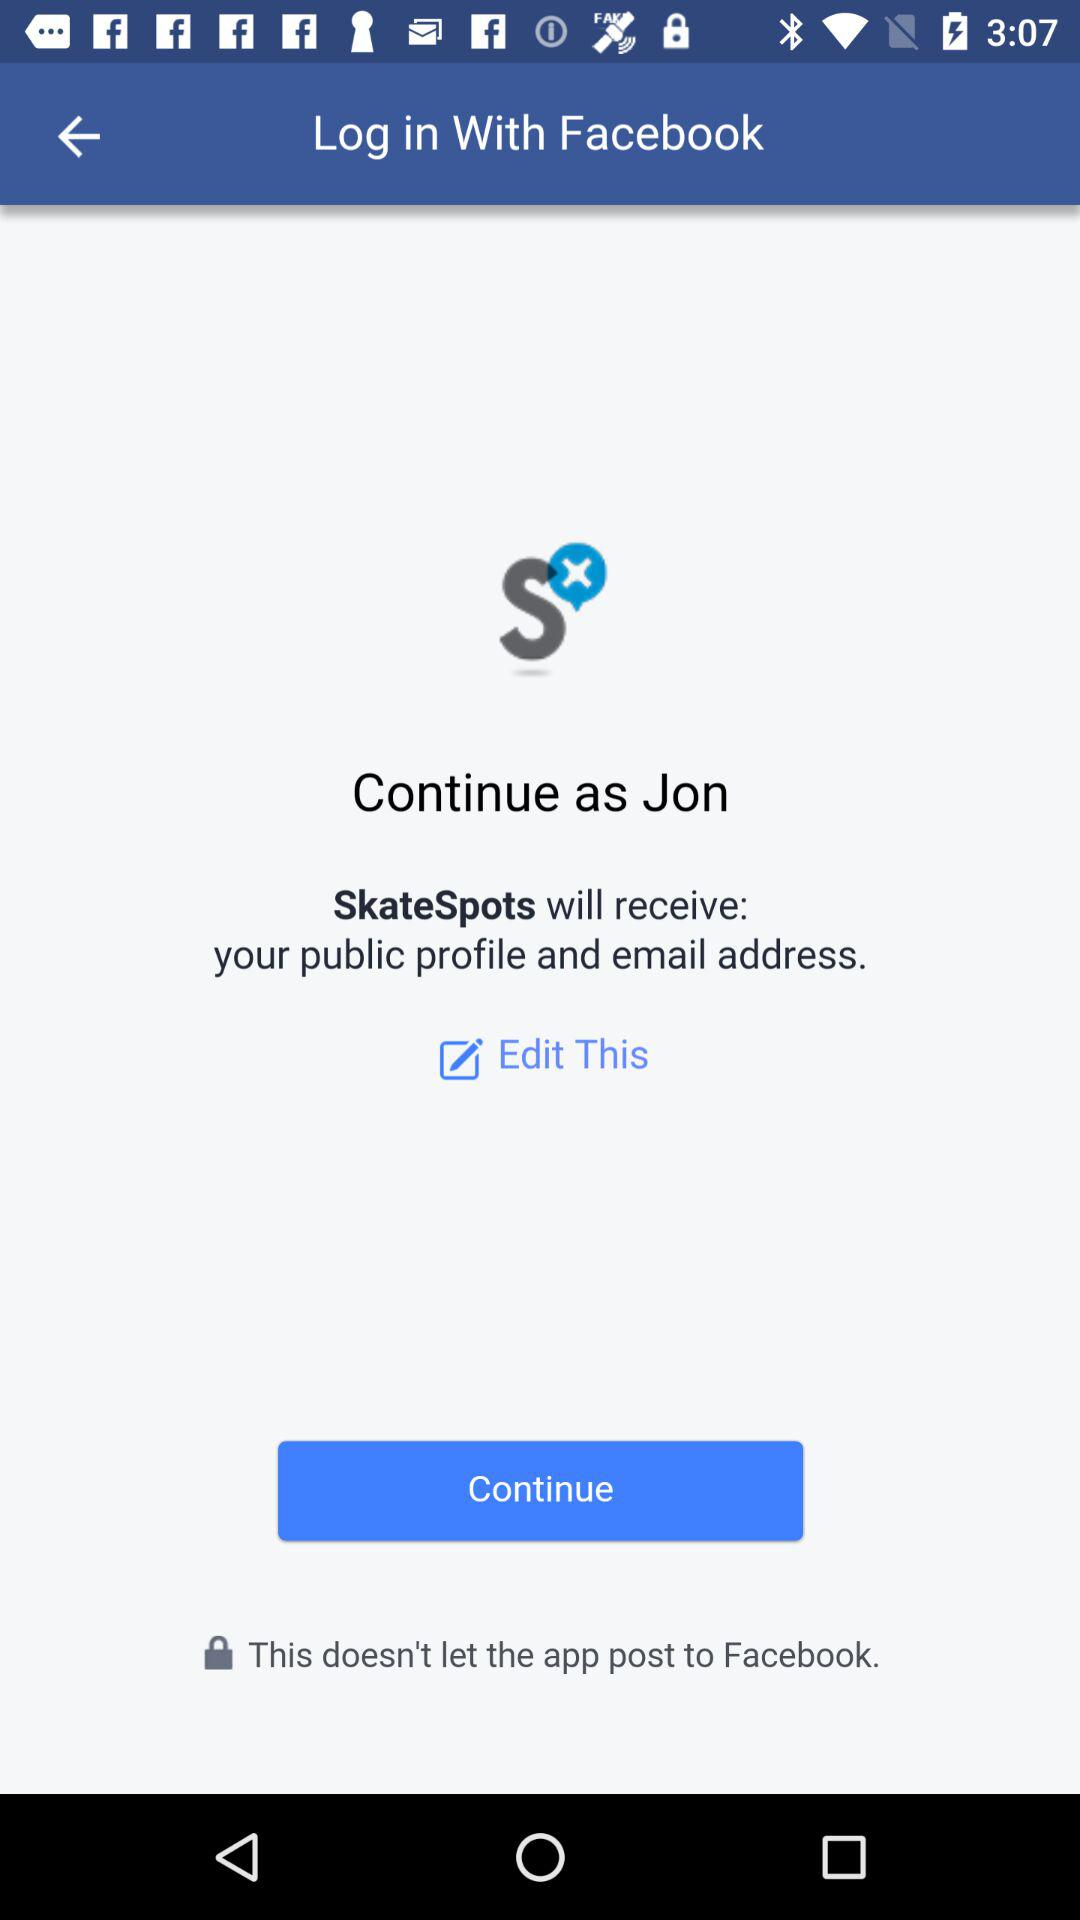Who will receive the public profile and email address? The application "SkateSpots" will receive the public profile and email address. 